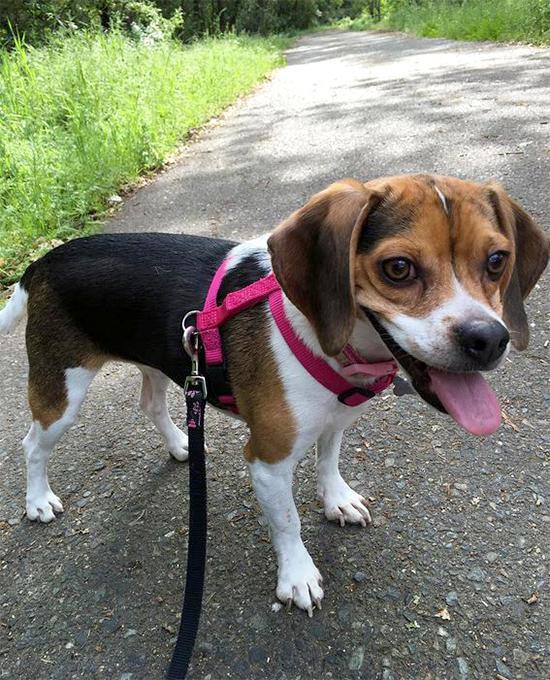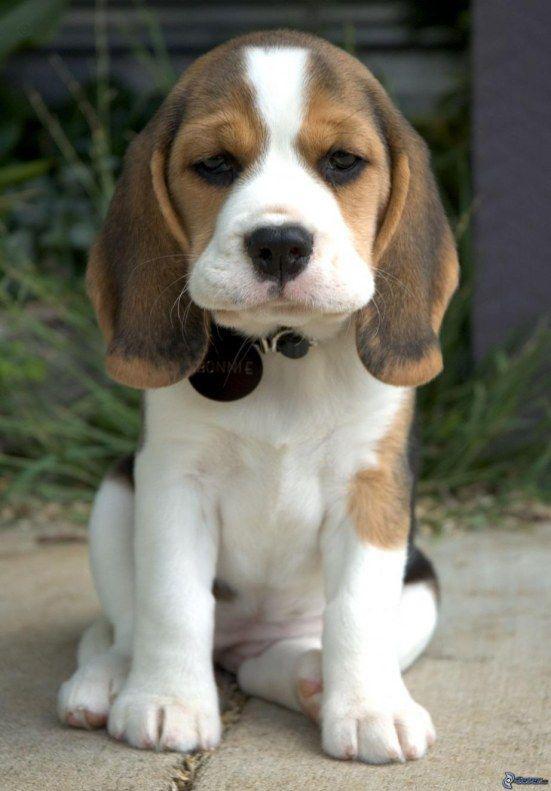The first image is the image on the left, the second image is the image on the right. Given the left and right images, does the statement "The dog in the image on the left is wearing a leash." hold true? Answer yes or no. Yes. 